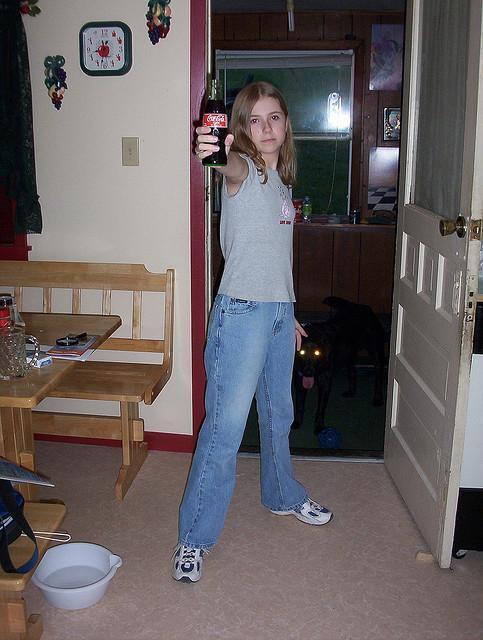How many trains are shown?
Give a very brief answer. 0. 